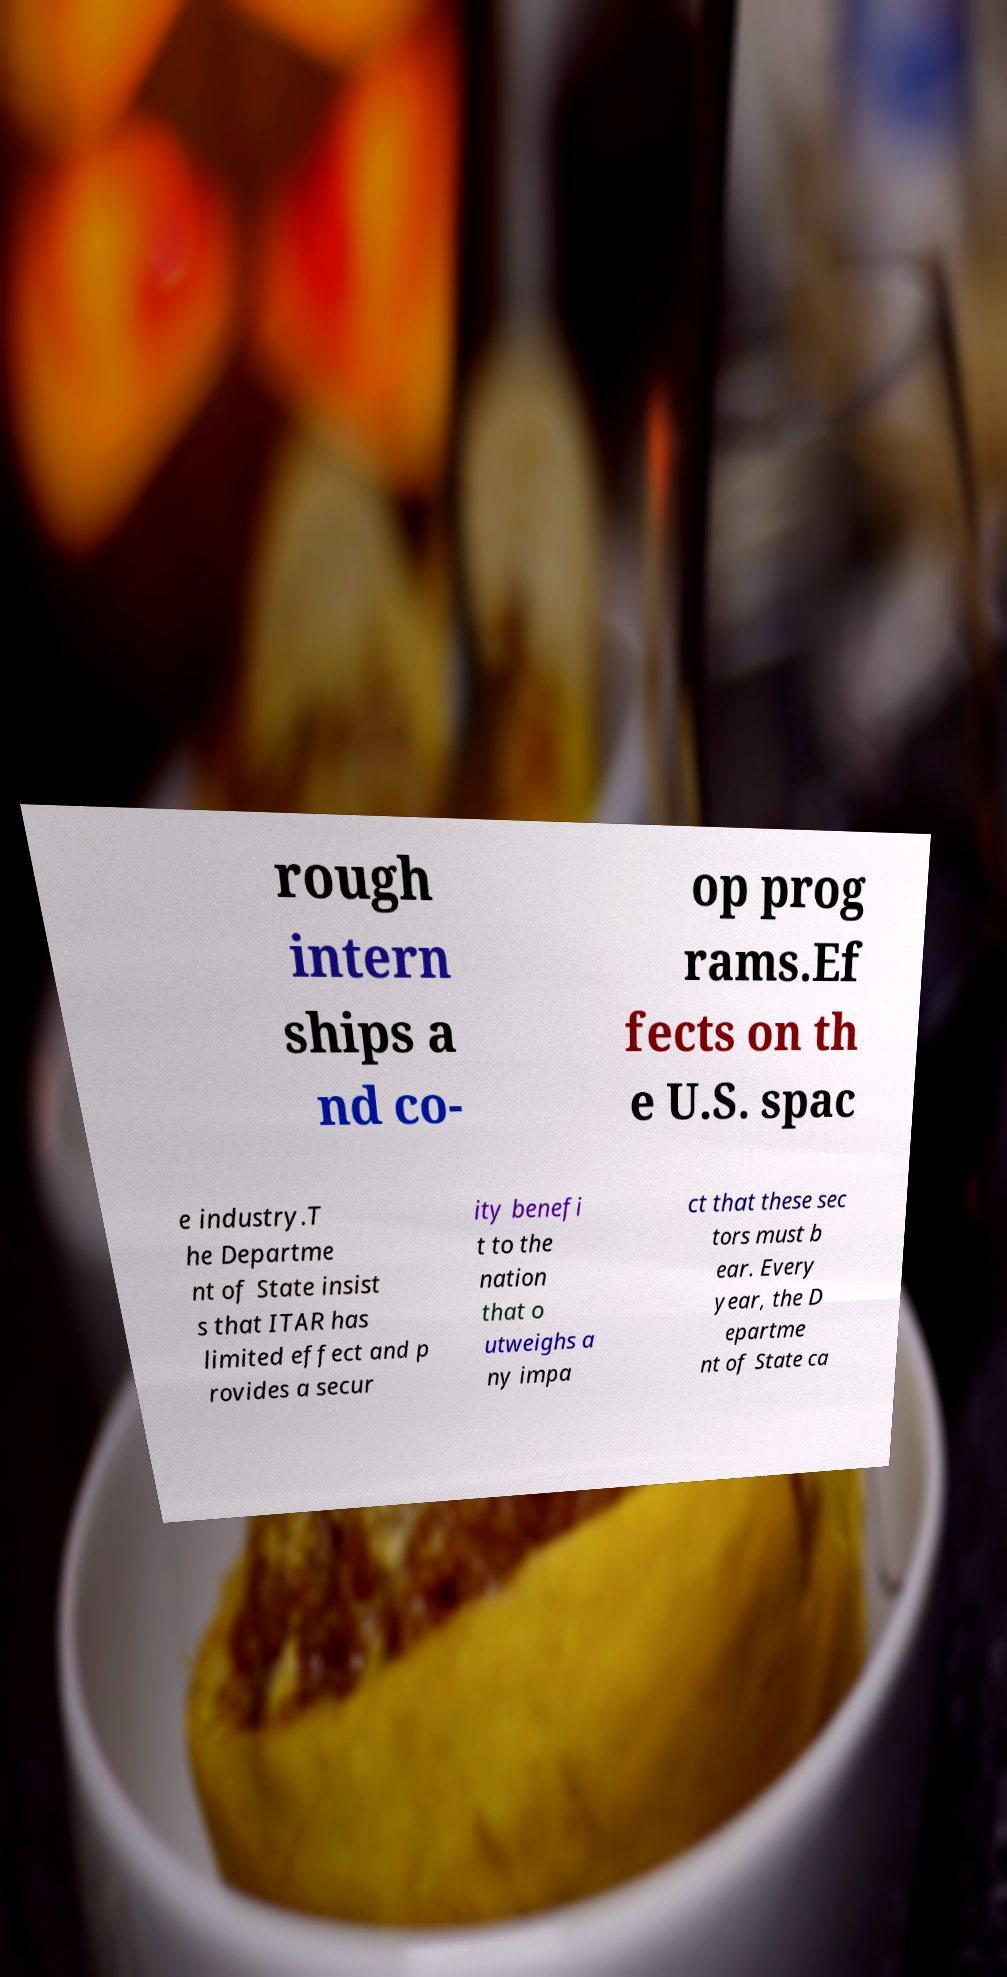There's text embedded in this image that I need extracted. Can you transcribe it verbatim? rough intern ships a nd co- op prog rams.Ef fects on th e U.S. spac e industry.T he Departme nt of State insist s that ITAR has limited effect and p rovides a secur ity benefi t to the nation that o utweighs a ny impa ct that these sec tors must b ear. Every year, the D epartme nt of State ca 